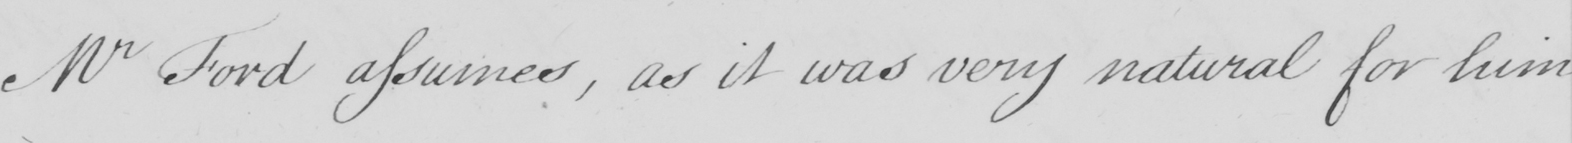What does this handwritten line say? Mr Ford assumes , as it was very natural for him 